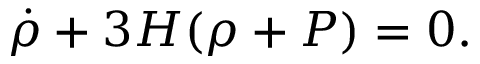<formula> <loc_0><loc_0><loc_500><loc_500>\dot { \rho } + 3 H ( \rho + P ) = 0 .</formula> 